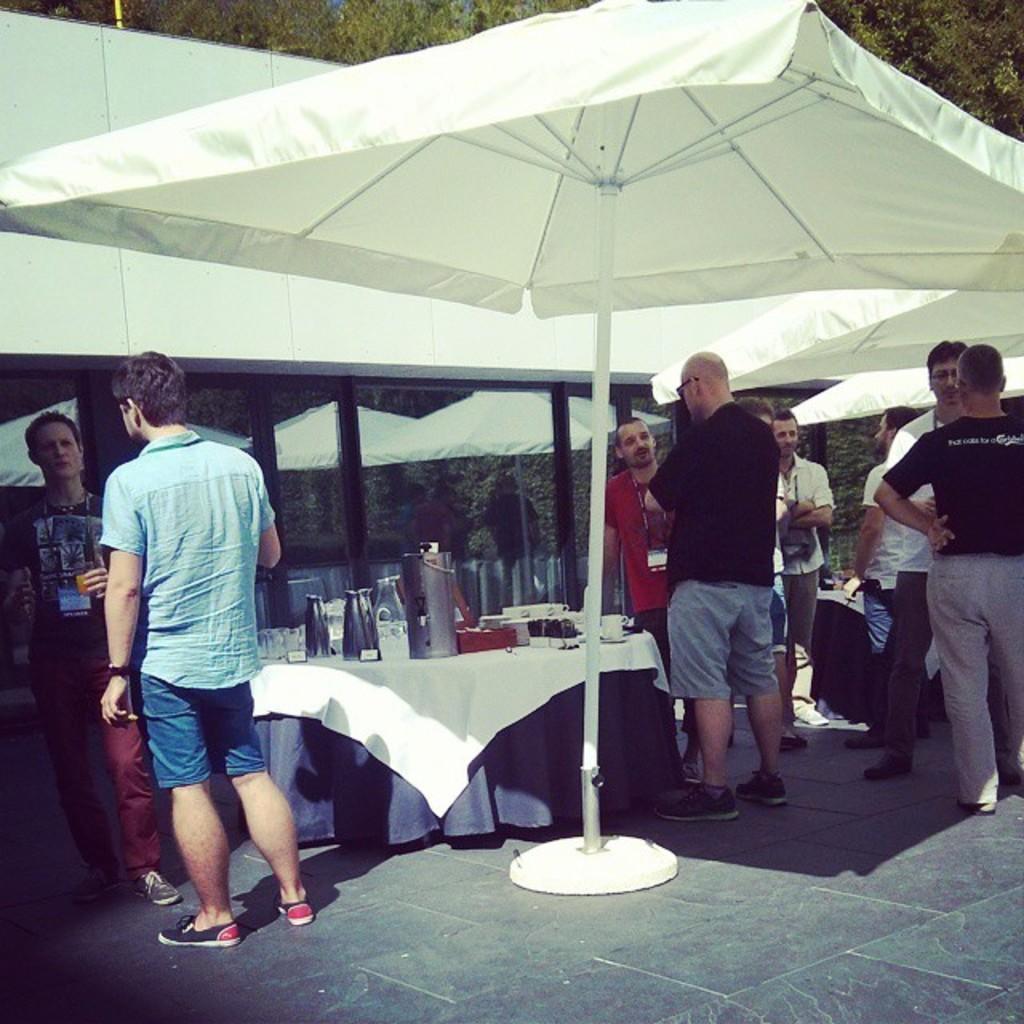Can you describe this image briefly? Here we can see a group of people standing, there is an umbrella in the middle of the image like a tent, the guy on the left side is holding a bottle, there a table in the center of image with glasses and bottles on it, there is a building behind them 